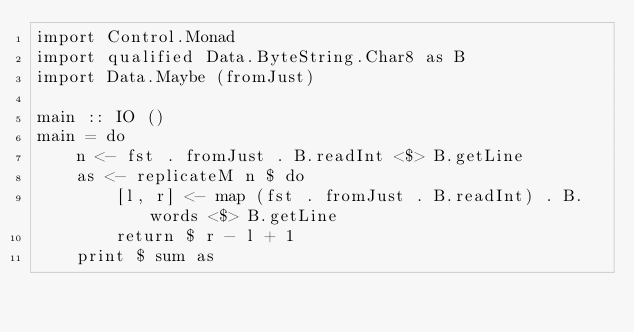Convert code to text. <code><loc_0><loc_0><loc_500><loc_500><_Haskell_>import Control.Monad
import qualified Data.ByteString.Char8 as B
import Data.Maybe (fromJust)

main :: IO ()
main = do
    n <- fst . fromJust . B.readInt <$> B.getLine
    as <- replicateM n $ do
        [l, r] <- map (fst . fromJust . B.readInt) . B.words <$> B.getLine
        return $ r - l + 1
    print $ sum as
</code> 